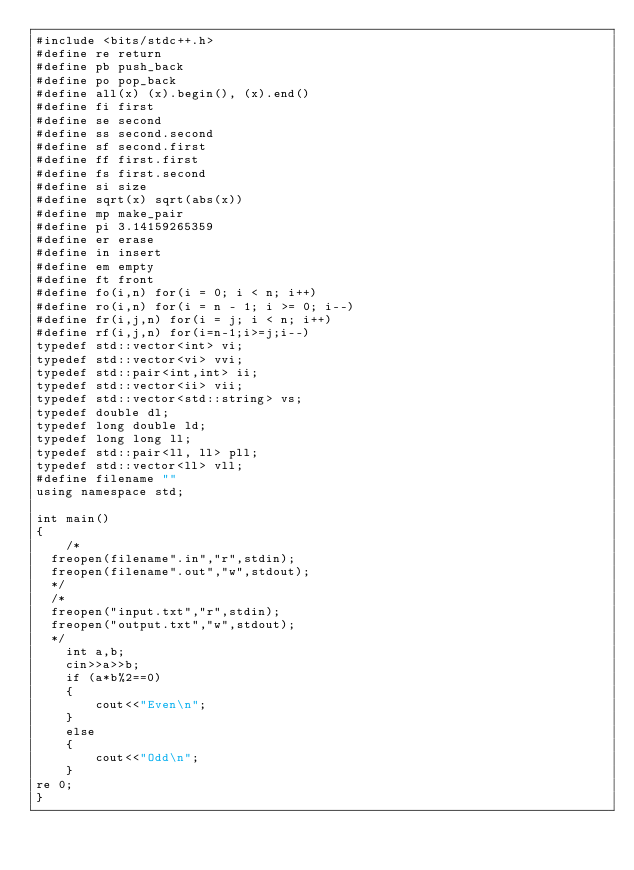Convert code to text. <code><loc_0><loc_0><loc_500><loc_500><_C++_>#include <bits/stdc++.h>
#define re return
#define pb push_back
#define po pop_back
#define all(x) (x).begin(), (x).end()
#define fi first
#define se second
#define ss second.second
#define sf second.first
#define ff first.first
#define fs first.second
#define si size
#define sqrt(x) sqrt(abs(x))
#define mp make_pair
#define pi 3.14159265359
#define er erase
#define in insert
#define em empty
#define ft front
#define fo(i,n) for(i = 0; i < n; i++)
#define ro(i,n) for(i = n - 1; i >= 0; i--)
#define fr(i,j,n) for(i = j; i < n; i++)
#define rf(i,j,n) for(i=n-1;i>=j;i--)
typedef std::vector<int> vi;
typedef std::vector<vi> vvi;
typedef std::pair<int,int> ii;
typedef std::vector<ii> vii;
typedef std::vector<std::string> vs;
typedef double dl;
typedef long double ld;
typedef long long ll;
typedef std::pair<ll, ll> pll;
typedef std::vector<ll> vll;
#define filename ""
using namespace std;

int main()
{
    /*
	freopen(filename".in","r",stdin);
	freopen(filename".out","w",stdout);
	*/
	/*
	freopen("input.txt","r",stdin);
	freopen("output.txt","w",stdout);
	*/
    int a,b;
    cin>>a>>b;
    if (a*b%2==0)
    {
        cout<<"Even\n";
    }
    else
    {
        cout<<"Odd\n";
    }
re 0;
}
</code> 